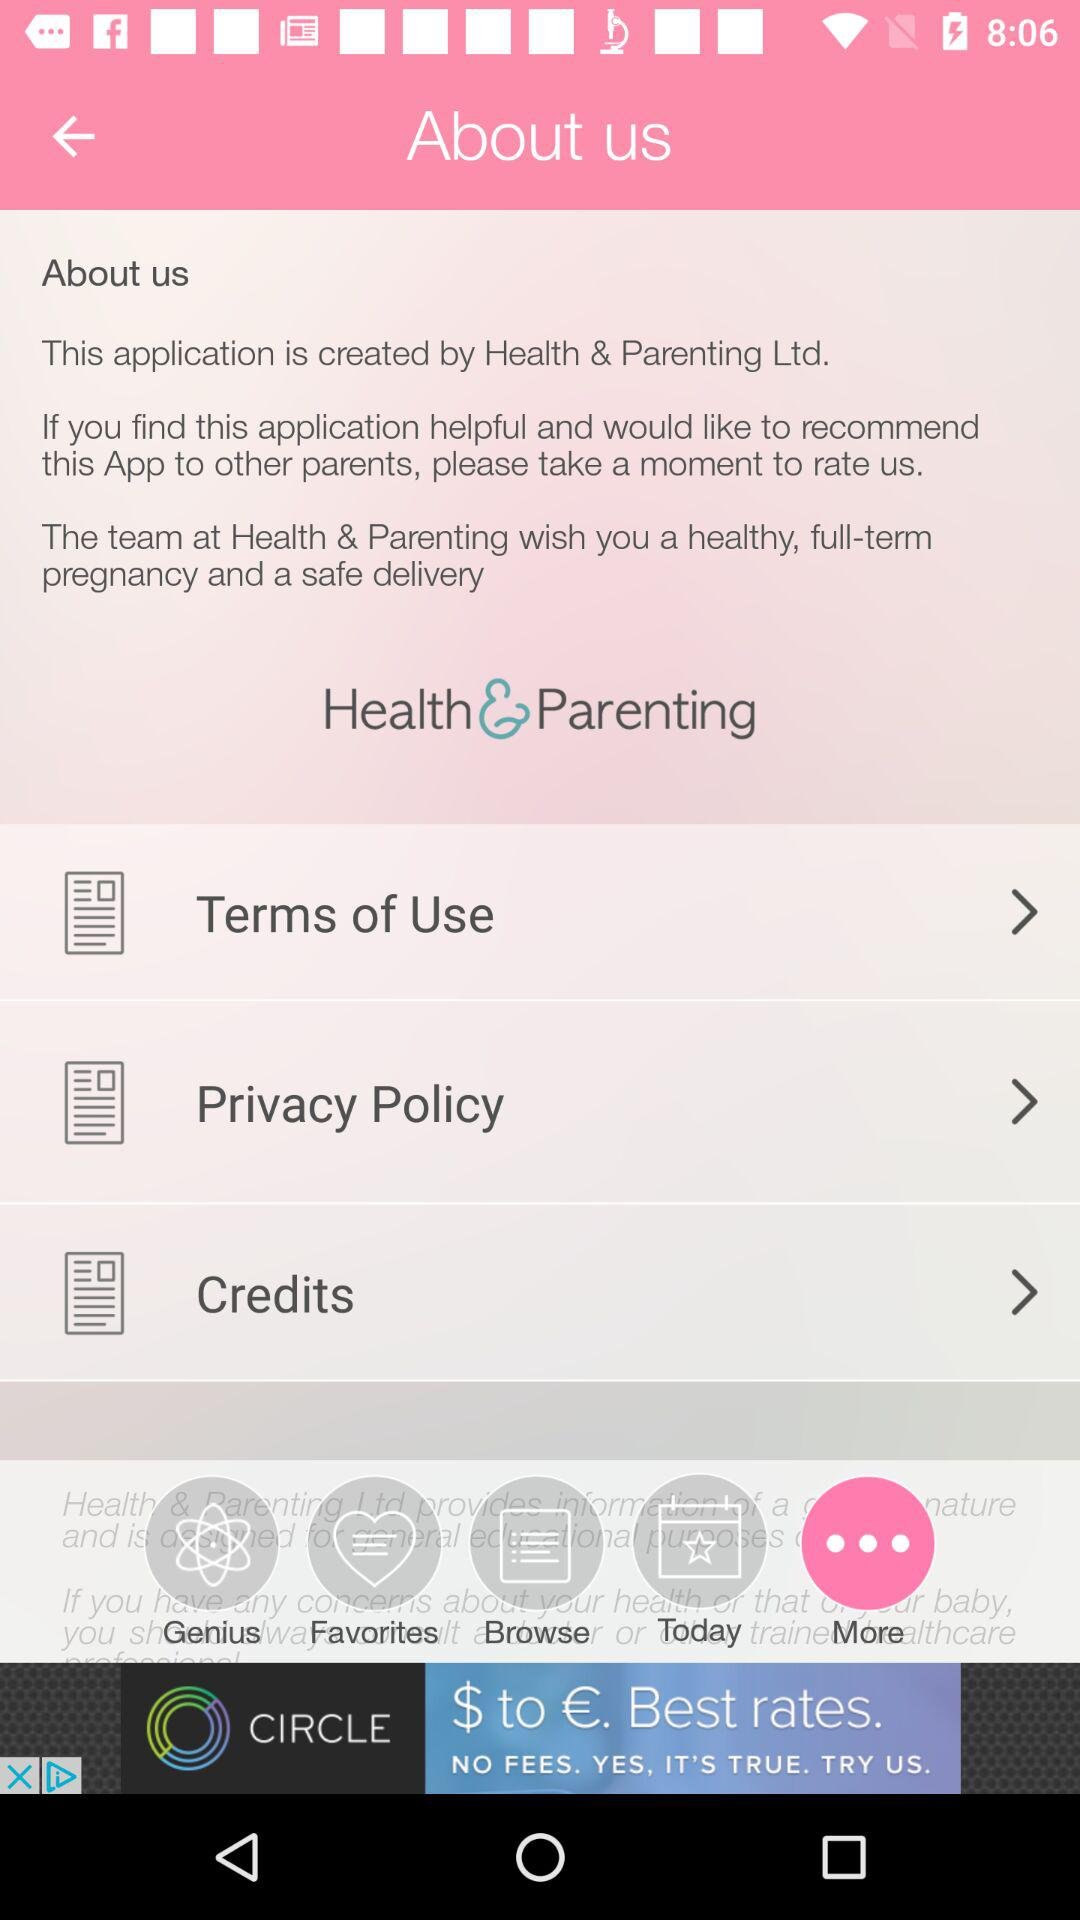What is the application name? The application name is "Health & Parenting". 